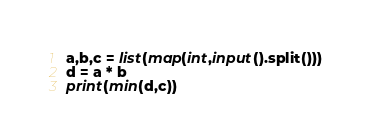Convert code to text. <code><loc_0><loc_0><loc_500><loc_500><_Python_>a,b,c = list(map(int,input().split()))
d = a * b
print(min(d,c))
</code> 